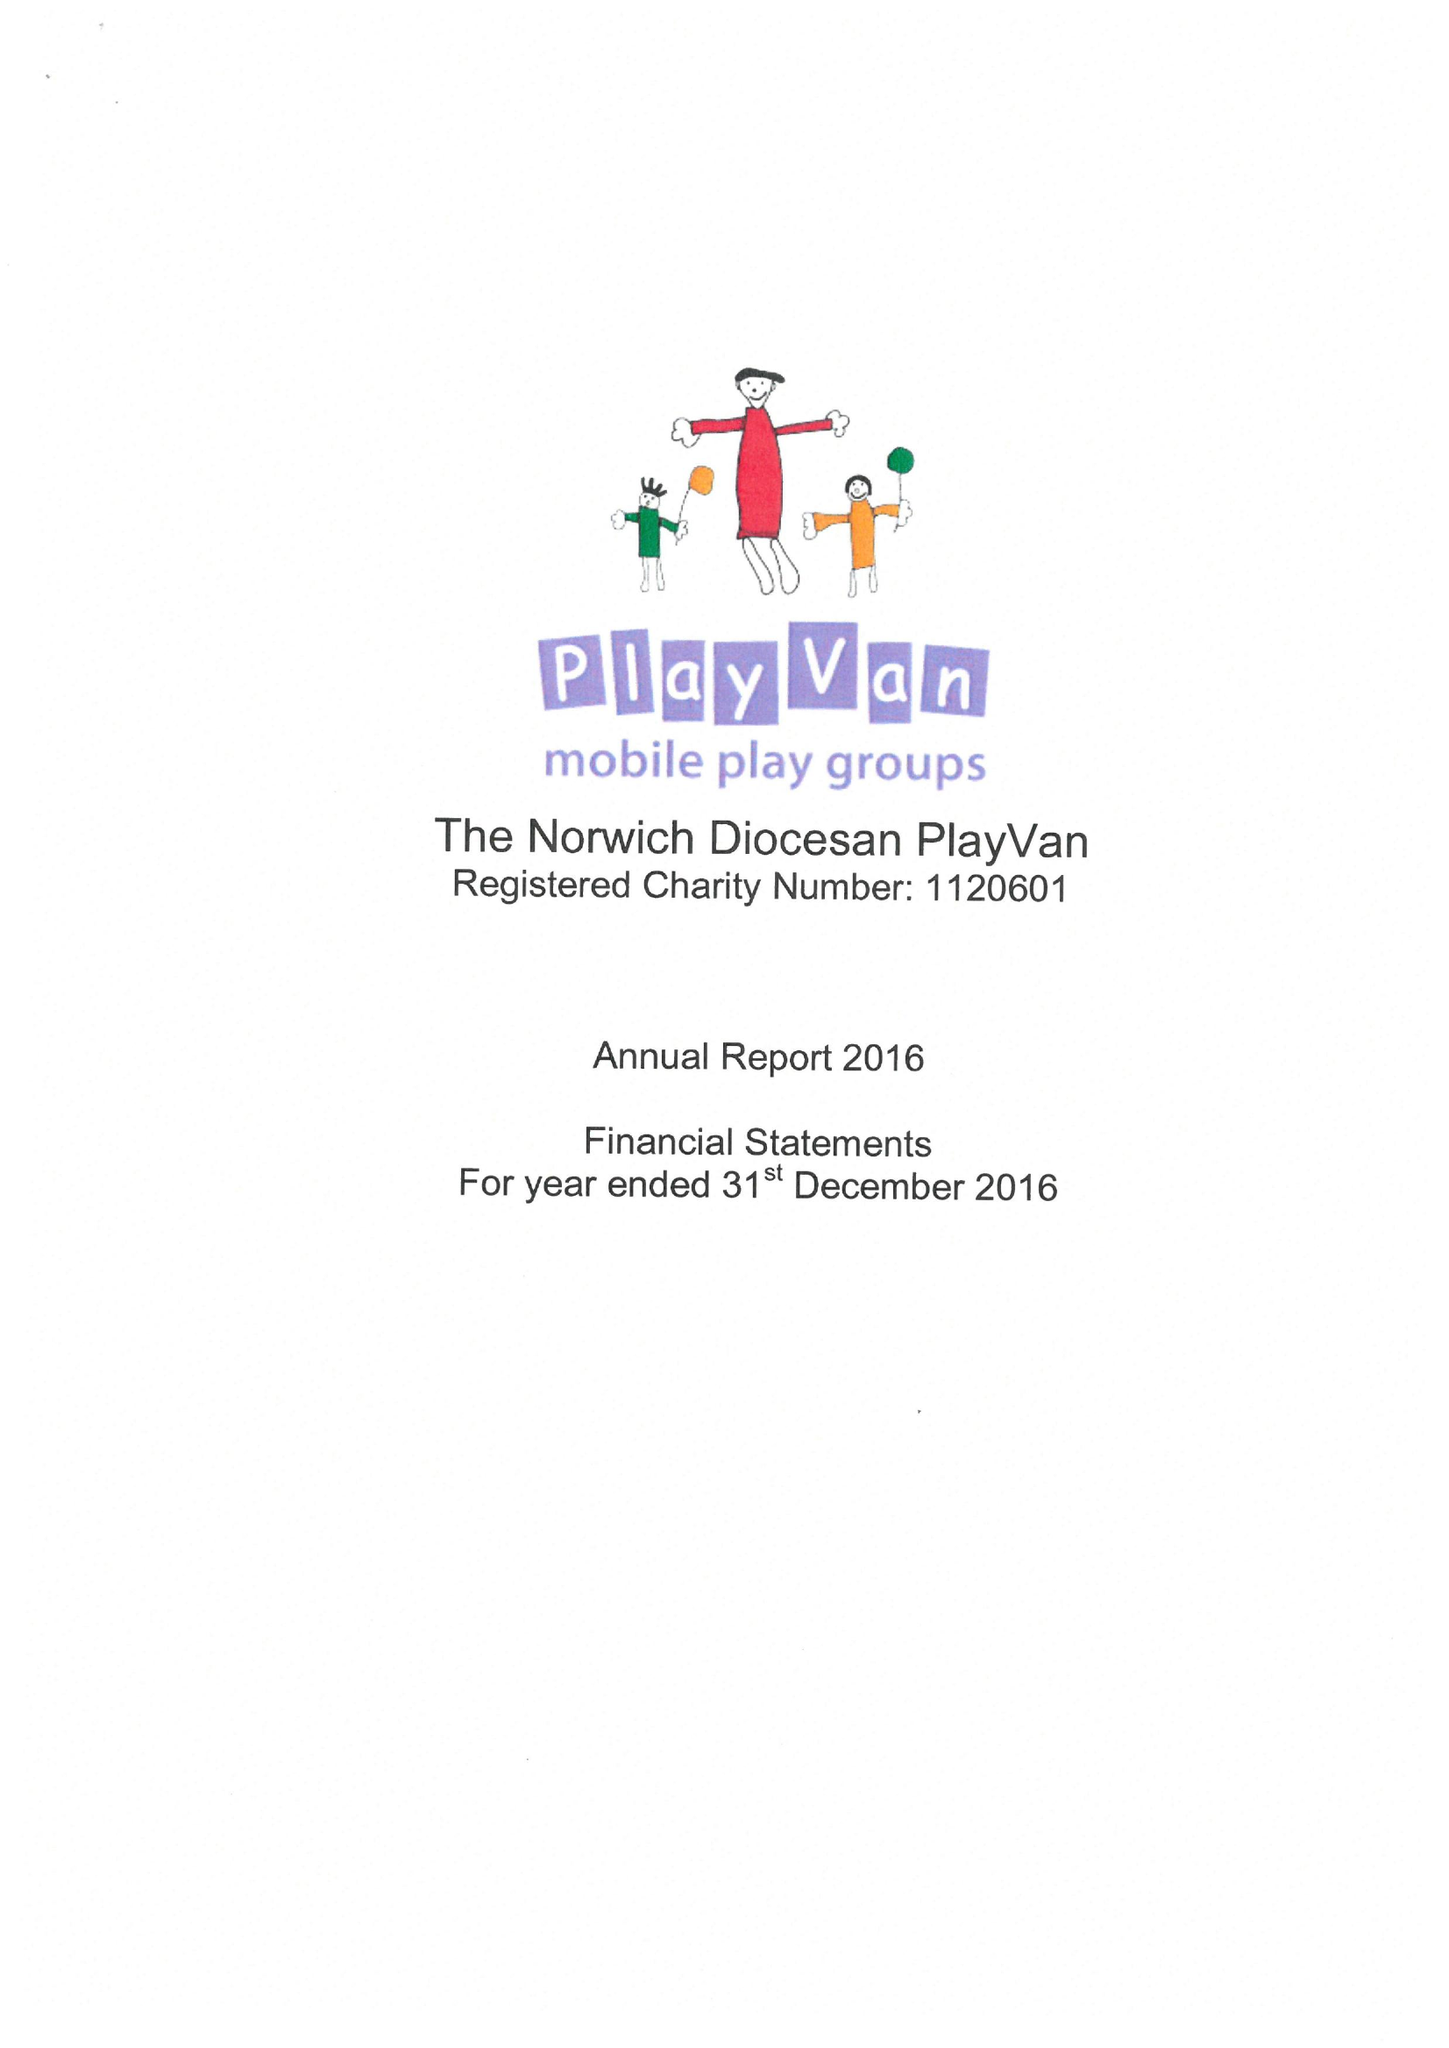What is the value for the income_annually_in_british_pounds?
Answer the question using a single word or phrase. 46969.00 